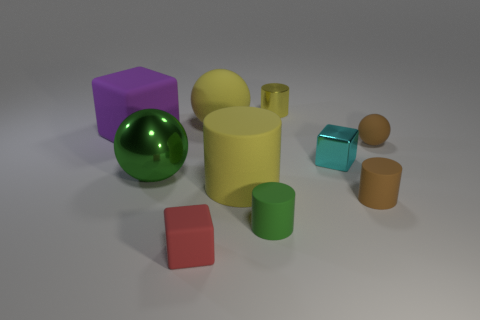Subtract 1 cylinders. How many cylinders are left? 3 Subtract all gray cylinders. Subtract all gray blocks. How many cylinders are left? 4 Subtract all cylinders. How many objects are left? 6 Add 7 small cylinders. How many small cylinders are left? 10 Add 3 purple things. How many purple things exist? 4 Subtract 1 yellow spheres. How many objects are left? 9 Subtract all small green rubber objects. Subtract all tiny cyan metallic objects. How many objects are left? 8 